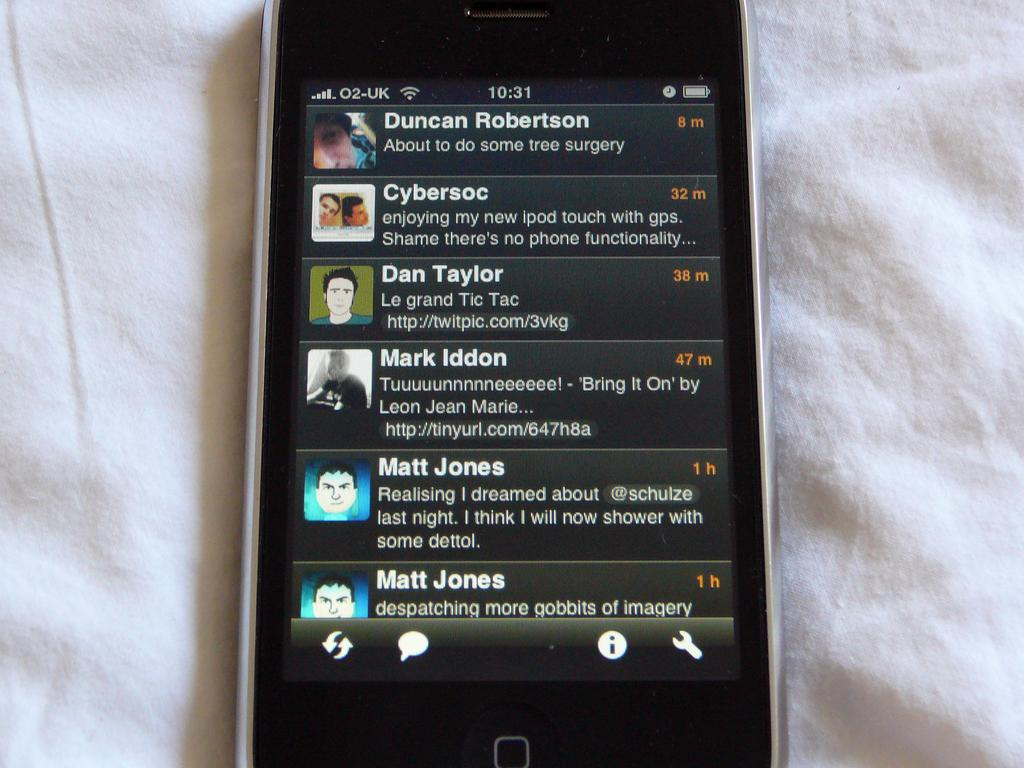<image>
Present a compact description of the photo's key features. A phone is open to a list of stories by people including Matt Jones. 